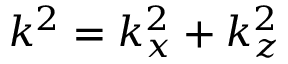Convert formula to latex. <formula><loc_0><loc_0><loc_500><loc_500>k ^ { 2 } = k _ { x } ^ { 2 } + k _ { z } ^ { 2 }</formula> 